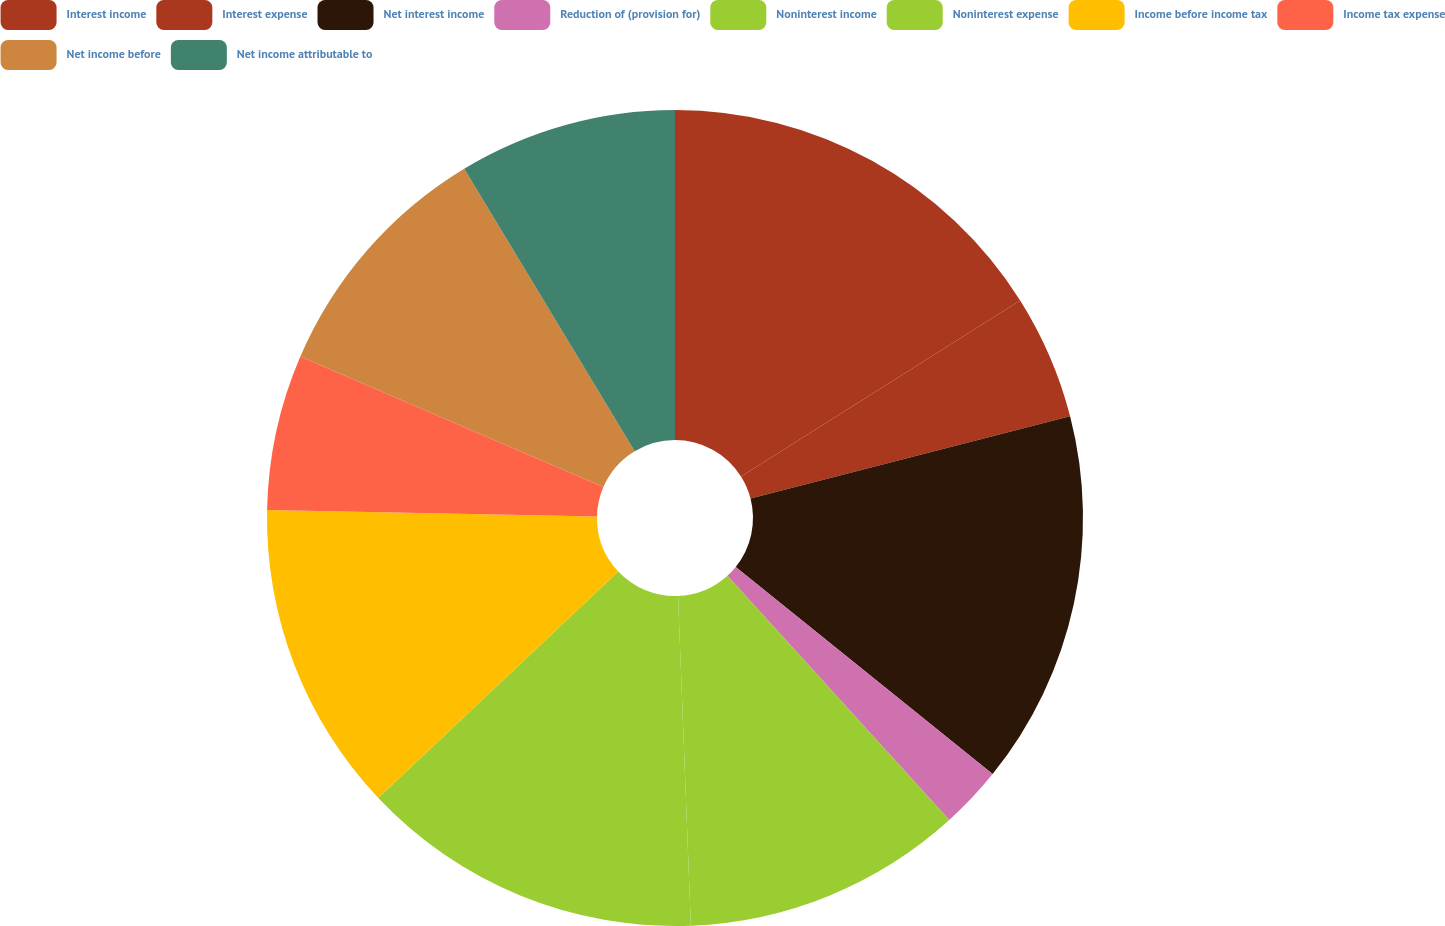Convert chart. <chart><loc_0><loc_0><loc_500><loc_500><pie_chart><fcel>Interest income<fcel>Interest expense<fcel>Net interest income<fcel>Reduction of (provision for)<fcel>Noninterest income<fcel>Noninterest expense<fcel>Income before income tax<fcel>Income tax expense<fcel>Net income before<fcel>Net income attributable to<nl><fcel>16.05%<fcel>4.94%<fcel>14.81%<fcel>2.47%<fcel>11.11%<fcel>13.58%<fcel>12.35%<fcel>6.17%<fcel>9.88%<fcel>8.64%<nl></chart> 